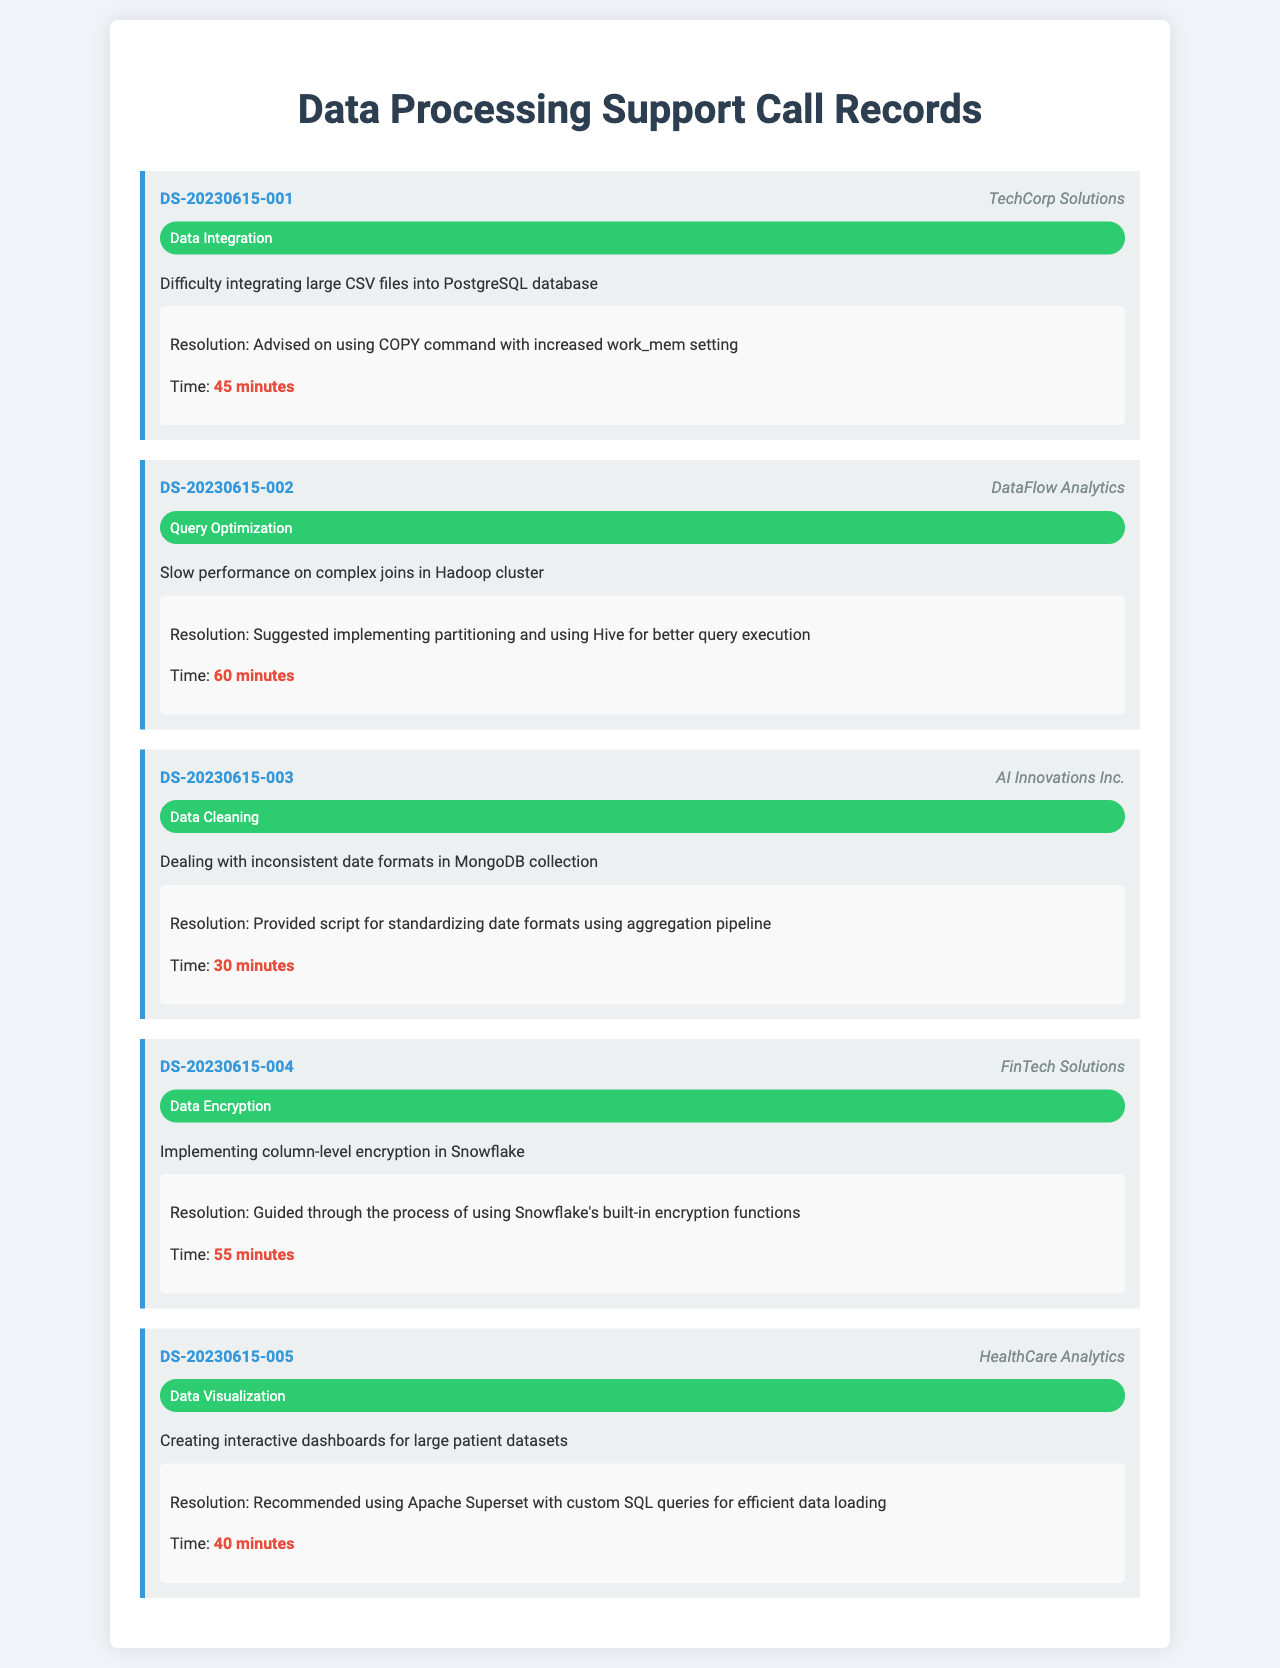What is the call ID for the first record? The call ID for the first record is DS-20230615-001.
Answer: DS-20230615-001 Which company had a query optimization issue? The company with a query optimization issue is DataFlow Analytics.
Answer: DataFlow Analytics How long did the resolution take for the data cleaning issue? The resolution time for the data cleaning issue is 30 minutes.
Answer: 30 minutes What type of issue was reported by FinTech Solutions? FinTech Solutions reported a data encryption issue.
Answer: Data Encryption What resolution was given for the interactive dashboards issue? The resolution recommended using Apache Superset with custom SQL queries for efficient data loading.
Answer: Apache Superset with custom SQL queries What issue type had the longest resolution time? The issue type with the longest resolution time is query optimization.
Answer: Query Optimization How many minutes did it take to resolve the data integration issue? It took 45 minutes to resolve the data integration issue.
Answer: 45 minutes What was suggested for improving query execution in DataFlow Analytics' call? The suggestion for improving query execution involved implementing partitioning and using Hive.
Answer: Implementing partitioning and using Hive Which company faced issues with inconsistent date formats? The company that faced issues with inconsistent date formats is AI Innovations Inc.
Answer: AI Innovations Inc 